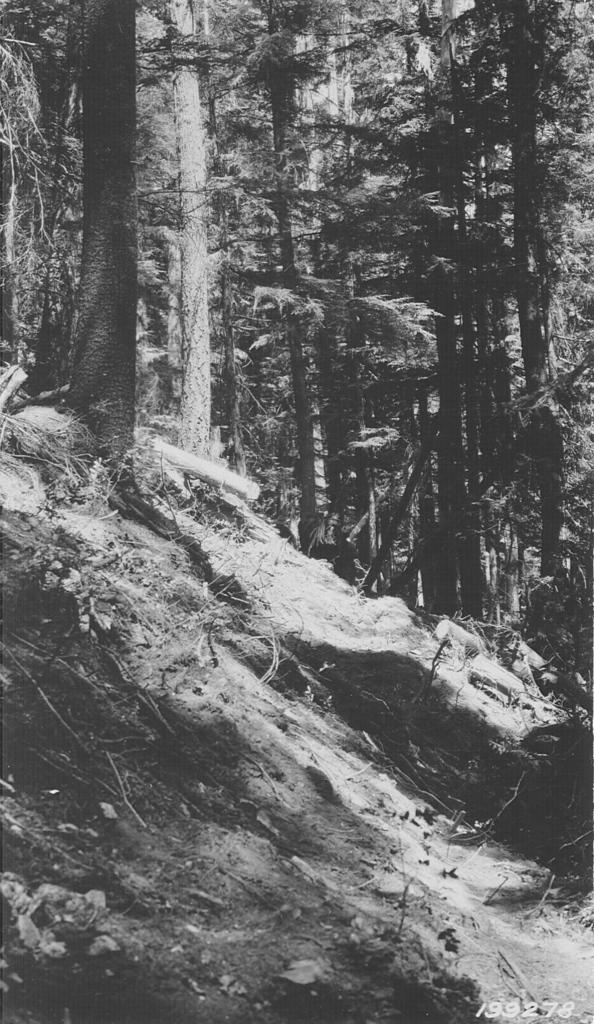What is the color scheme of the image? The image is black and white. What type of vegetation can be seen in the image? There are tall trees and plants in the image. What type of punishment is being handed out in the image? There is no indication of punishment in the image; it features tall trees and plants in a black and white color scheme. What decision is being made in the image? There is no decision-making process depicted in the image; it simply shows tall trees and plants in a black and white color scheme. 